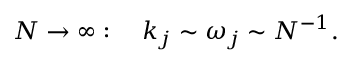Convert formula to latex. <formula><loc_0><loc_0><loc_500><loc_500>N \to \infty \colon \quad k _ { j } \sim \omega _ { j } \sim N ^ { - 1 } .</formula> 